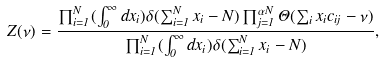Convert formula to latex. <formula><loc_0><loc_0><loc_500><loc_500>Z ( \nu ) = \frac { \prod _ { i = 1 } ^ { N } ( \int _ { 0 } ^ { \infty } d x _ { i } ) \delta ( \sum _ { i = 1 } ^ { N } x _ { i } - N ) \prod _ { j = 1 } ^ { \alpha N } \Theta ( \sum _ { i } x _ { i } c _ { i j } - \nu ) } { \prod _ { i = 1 } ^ { N } ( \int _ { 0 } ^ { \infty } d x _ { i } ) \delta ( \sum _ { i = 1 } ^ { N } x _ { i } - N ) } ,</formula> 